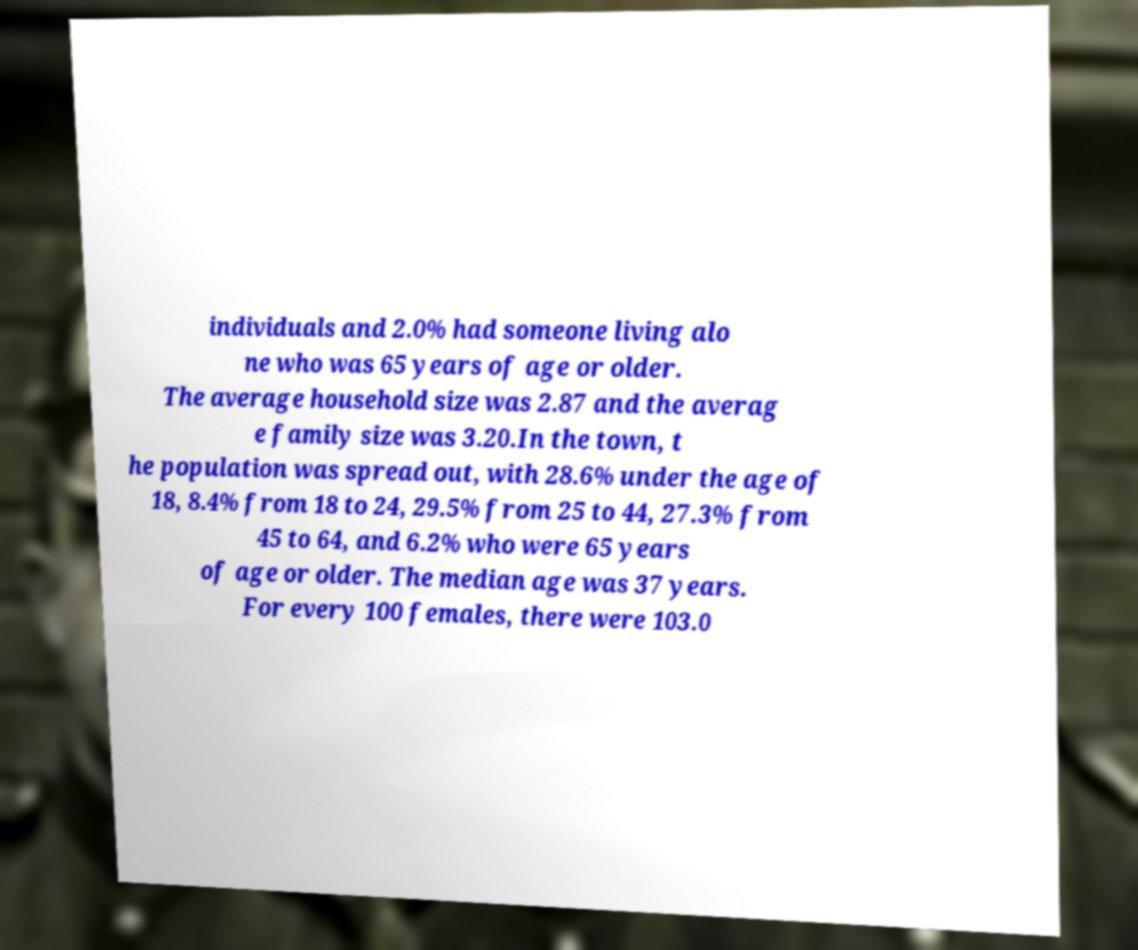For documentation purposes, I need the text within this image transcribed. Could you provide that? individuals and 2.0% had someone living alo ne who was 65 years of age or older. The average household size was 2.87 and the averag e family size was 3.20.In the town, t he population was spread out, with 28.6% under the age of 18, 8.4% from 18 to 24, 29.5% from 25 to 44, 27.3% from 45 to 64, and 6.2% who were 65 years of age or older. The median age was 37 years. For every 100 females, there were 103.0 